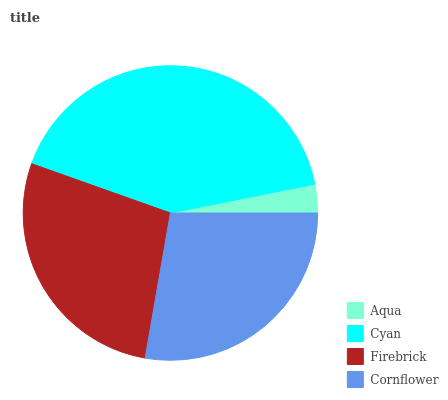Is Aqua the minimum?
Answer yes or no. Yes. Is Cyan the maximum?
Answer yes or no. Yes. Is Firebrick the minimum?
Answer yes or no. No. Is Firebrick the maximum?
Answer yes or no. No. Is Cyan greater than Firebrick?
Answer yes or no. Yes. Is Firebrick less than Cyan?
Answer yes or no. Yes. Is Firebrick greater than Cyan?
Answer yes or no. No. Is Cyan less than Firebrick?
Answer yes or no. No. Is Cornflower the high median?
Answer yes or no. Yes. Is Firebrick the low median?
Answer yes or no. Yes. Is Firebrick the high median?
Answer yes or no. No. Is Cyan the low median?
Answer yes or no. No. 